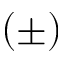<formula> <loc_0><loc_0><loc_500><loc_500>( \pm )</formula> 